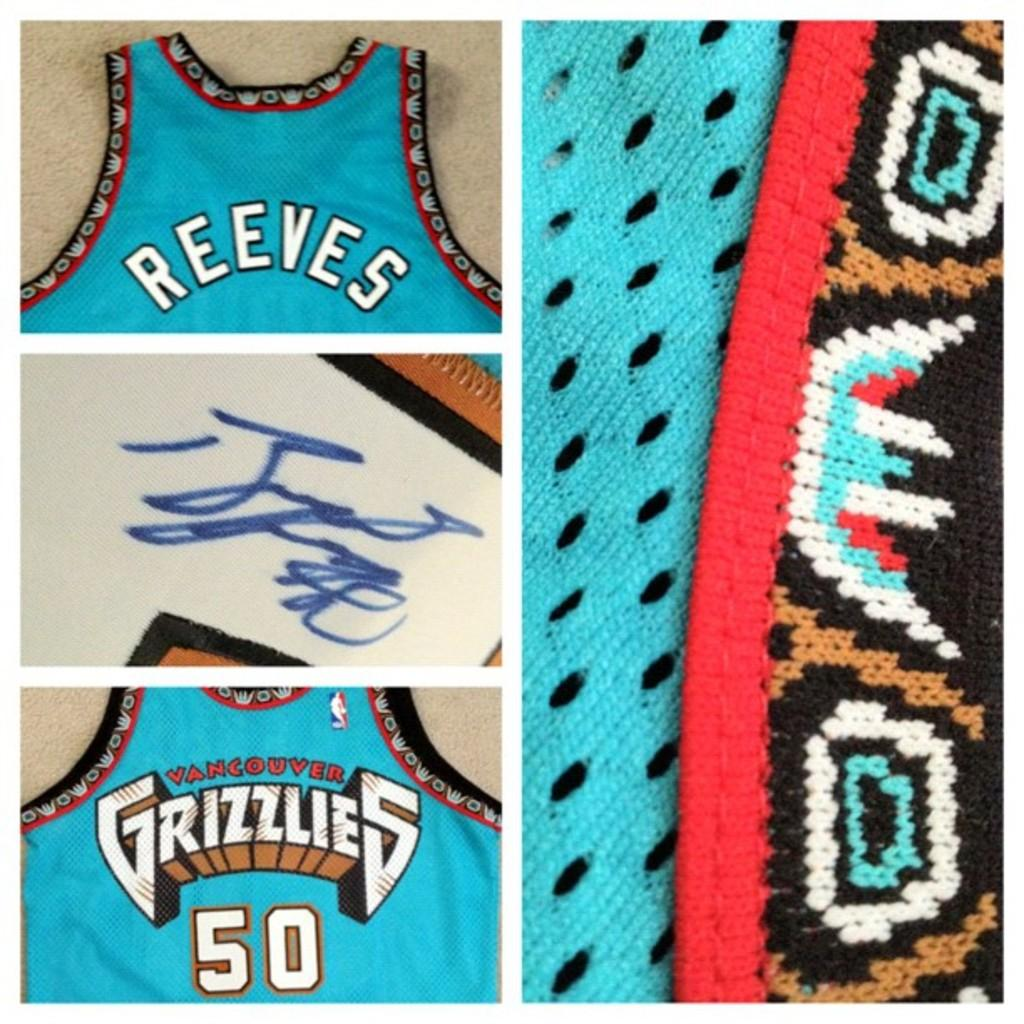<image>
Write a terse but informative summary of the picture. A jersey of Reeves with a signature from the team Grizzlies 